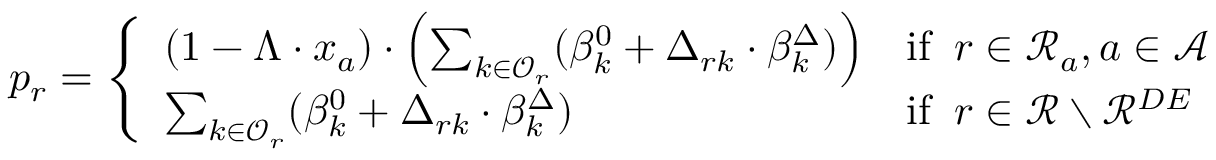<formula> <loc_0><loc_0><loc_500><loc_500>p _ { r } = \left \{ \begin{array} { l l } { ( 1 - \Lambda \cdot x _ { a } ) \cdot \left ( \sum _ { k \in \mathcal { O } _ { r } } ( \beta _ { k } ^ { 0 } + \Delta _ { r k } \cdot \beta _ { k } ^ { \Delta } ) \right ) } & { i f \, r \in \mathcal { R } _ { a } , a \in \mathcal { A } } \\ { \sum _ { k \in \mathcal { O } _ { r } } ( \beta _ { k } ^ { 0 } + \Delta _ { r k } \cdot \beta _ { k } ^ { \Delta } ) } & { i f \, r \in \mathcal { R } \ \mathcal { R } ^ { D E } } \end{array}</formula> 